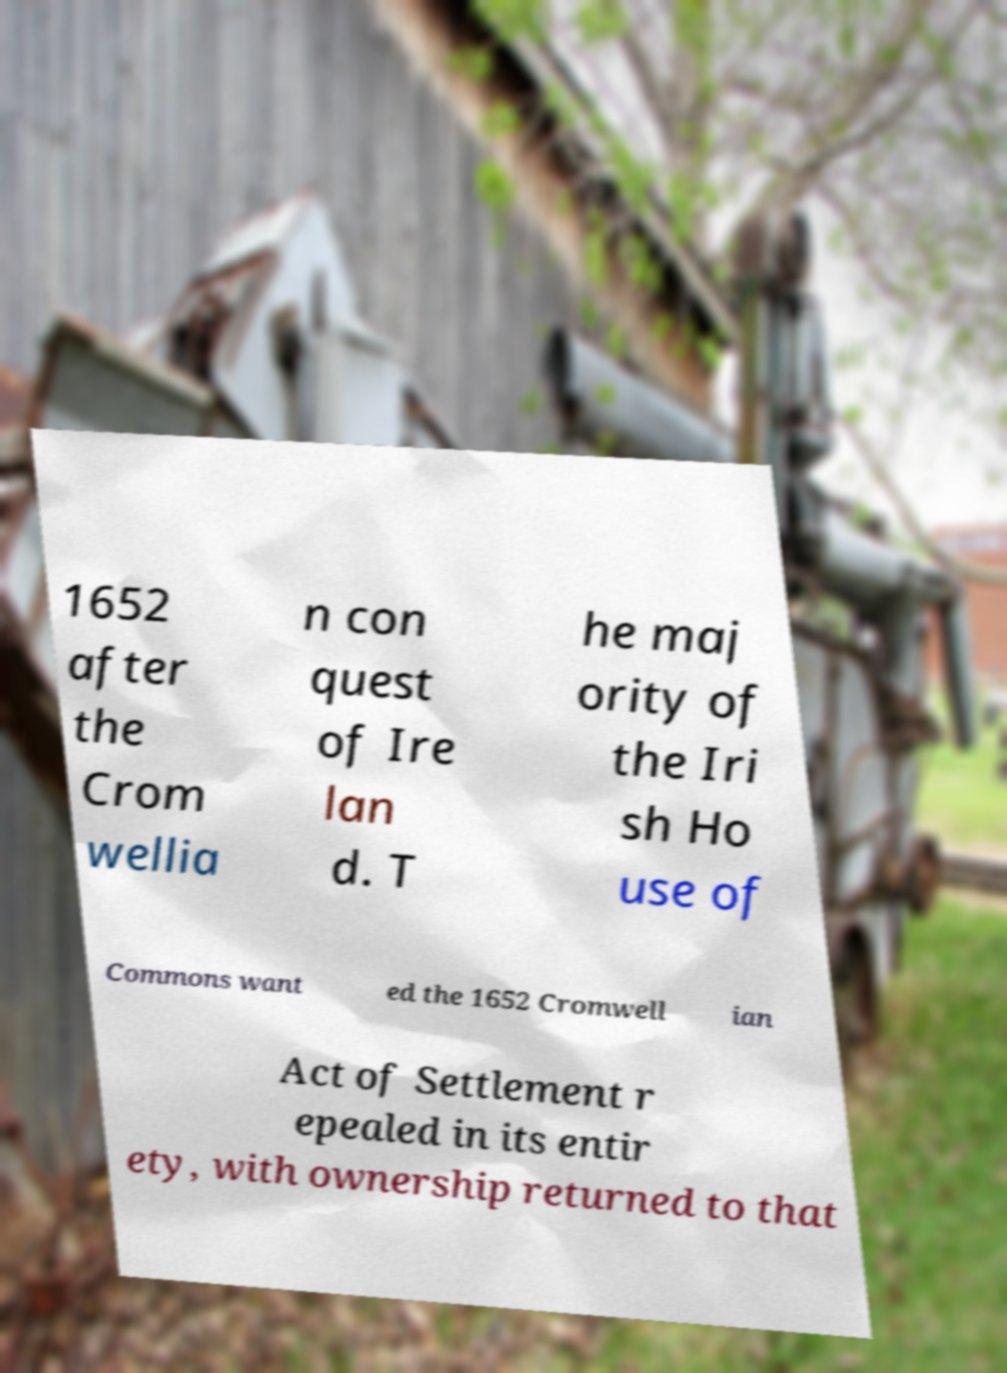Can you accurately transcribe the text from the provided image for me? 1652 after the Crom wellia n con quest of Ire lan d. T he maj ority of the Iri sh Ho use of Commons want ed the 1652 Cromwell ian Act of Settlement r epealed in its entir ety, with ownership returned to that 